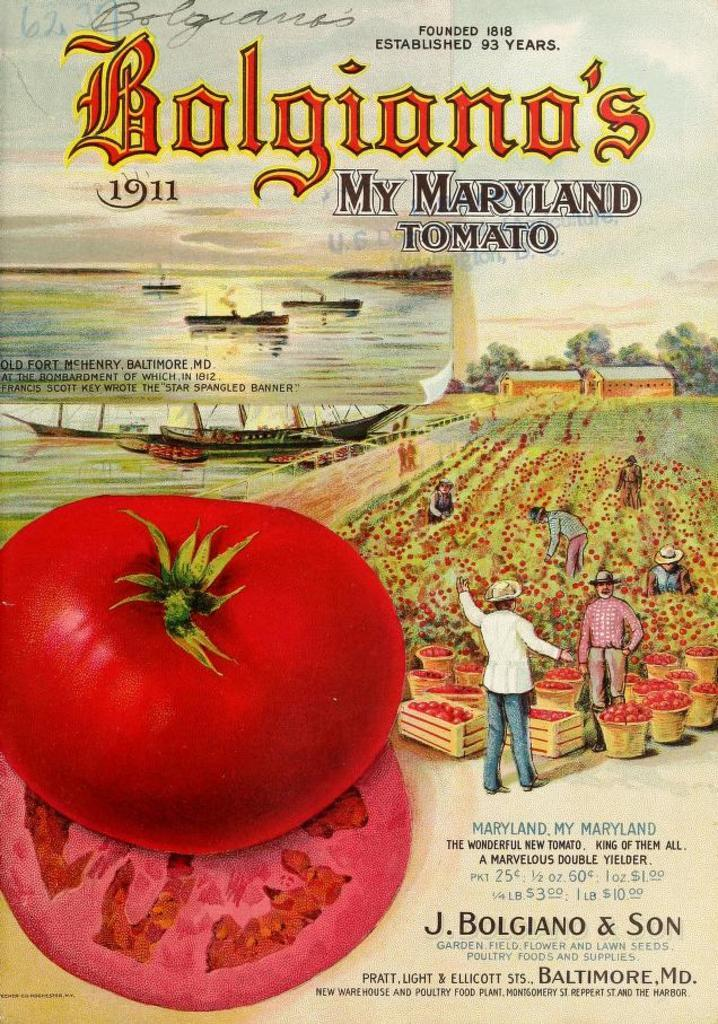What is featured on the poster in the image? The poster contains text. What type of object is present in the image that is typically used for holding or displaying items? There is a frame in the image. What is the red, round object in the image? There is a tomato in the image. Can you describe the people in the image? There are people in the image, but their specific characteristics are not mentioned in the provided facts. What type of umbrella is being used by the people in the image? There is no umbrella present in the image. Can you tell me how many cars are parked near the people in the image? There is no mention of cars in the image. 